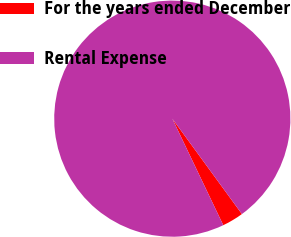Convert chart. <chart><loc_0><loc_0><loc_500><loc_500><pie_chart><fcel>For the years ended December<fcel>Rental Expense<nl><fcel>2.93%<fcel>97.07%<nl></chart> 